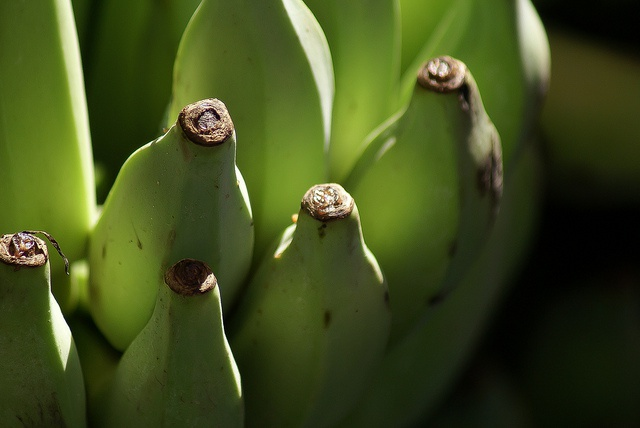Describe the objects in this image and their specific colors. I can see banana in darkgreen, olive, and black tones, banana in darkgreen, black, and olive tones, banana in darkgreen, black, and ivory tones, banana in darkgreen, black, and olive tones, and banana in darkgreen, olive, and khaki tones in this image. 